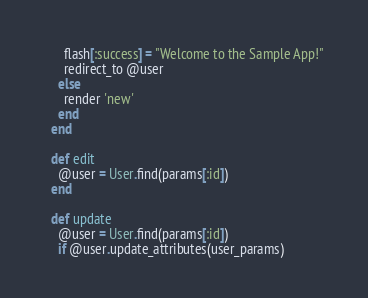Convert code to text. <code><loc_0><loc_0><loc_500><loc_500><_Ruby_>      flash[:success] = "Welcome to the Sample App!"
      redirect_to @user
    else
      render 'new'
    end
  end

  def edit
    @user = User.find(params[:id])
  end

  def update
    @user = User.find(params[:id])
    if @user.update_attributes(user_params)</code> 